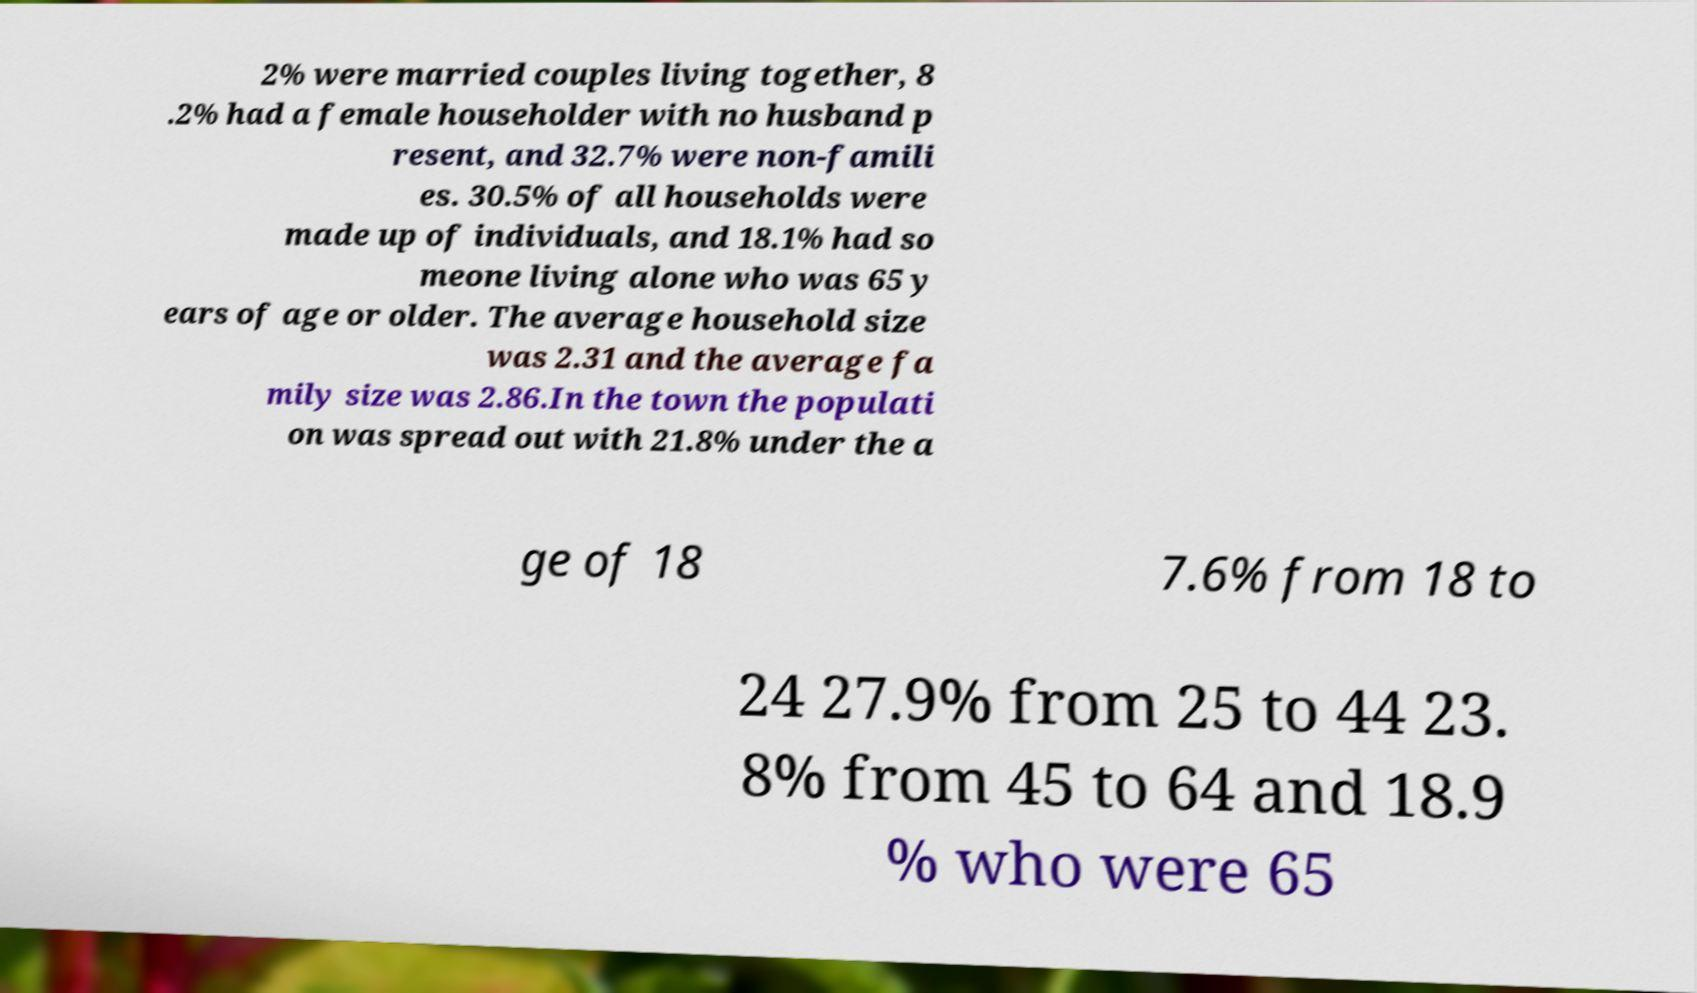Please read and relay the text visible in this image. What does it say? 2% were married couples living together, 8 .2% had a female householder with no husband p resent, and 32.7% were non-famili es. 30.5% of all households were made up of individuals, and 18.1% had so meone living alone who was 65 y ears of age or older. The average household size was 2.31 and the average fa mily size was 2.86.In the town the populati on was spread out with 21.8% under the a ge of 18 7.6% from 18 to 24 27.9% from 25 to 44 23. 8% from 45 to 64 and 18.9 % who were 65 